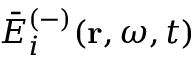<formula> <loc_0><loc_0><loc_500><loc_500>\bar { E } _ { i } ^ { ( - ) } ( r , \omega , t )</formula> 